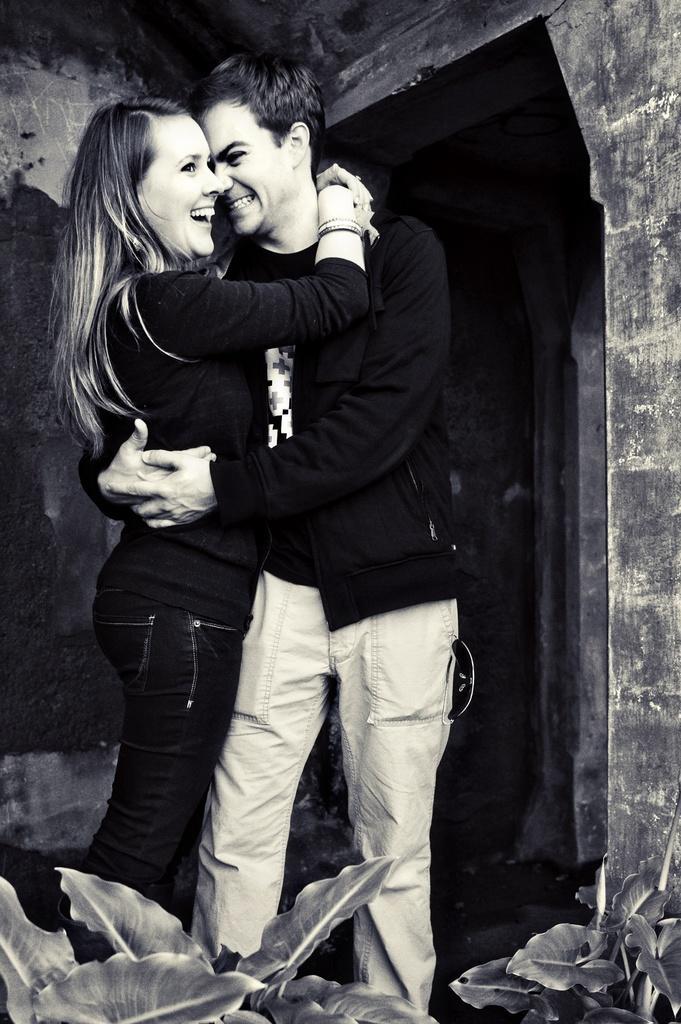How would you summarize this image in a sentence or two? It looks like a black and white picture. We can see there are two people hugging each other and smiling. In front of the people there are plants and behind the people there is a wall. 